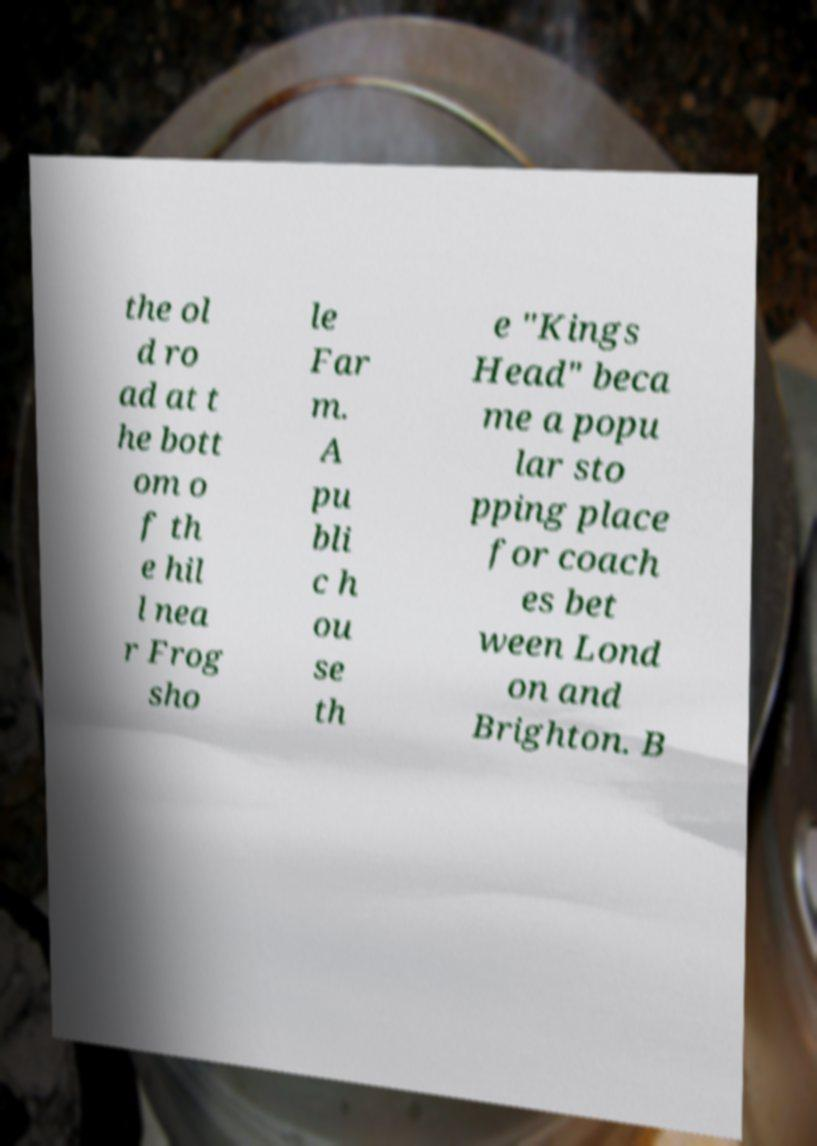Could you assist in decoding the text presented in this image and type it out clearly? the ol d ro ad at t he bott om o f th e hil l nea r Frog sho le Far m. A pu bli c h ou se th e "Kings Head" beca me a popu lar sto pping place for coach es bet ween Lond on and Brighton. B 